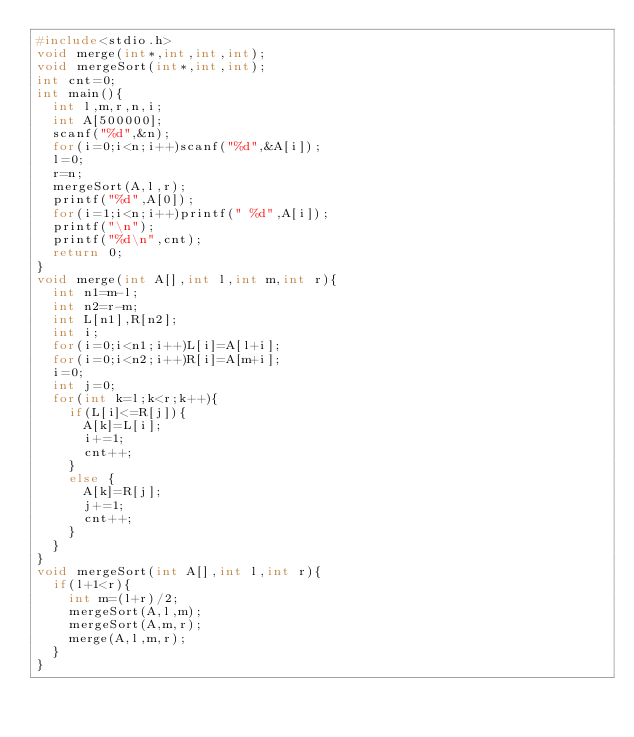Convert code to text. <code><loc_0><loc_0><loc_500><loc_500><_C_>#include<stdio.h>
void merge(int*,int,int,int);
void mergeSort(int*,int,int);
int cnt=0;
int main(){
  int l,m,r,n,i;
  int A[500000];
  scanf("%d",&n);
  for(i=0;i<n;i++)scanf("%d",&A[i]);
  l=0;
  r=n;
  mergeSort(A,l,r);
  printf("%d",A[0]);
  for(i=1;i<n;i++)printf(" %d",A[i]);
  printf("\n");
  printf("%d\n",cnt);
  return 0;
}
void merge(int A[],int l,int m,int r){
  int n1=m-l;
  int n2=r-m;
  int L[n1],R[n2];
  int i;
  for(i=0;i<n1;i++)L[i]=A[l+i];
  for(i=0;i<n2;i++)R[i]=A[m+i];
  i=0;
  int j=0;
  for(int k=l;k<r;k++){
    if(L[i]<=R[j]){
      A[k]=L[i];
      i+=1;
      cnt++;
    }
    else {
      A[k]=R[j];
      j+=1;
      cnt++;
    }
  }
}
void mergeSort(int A[],int l,int r){
  if(l+1<r){
    int m=(l+r)/2;
    mergeSort(A,l,m);
    mergeSort(A,m,r);
    merge(A,l,m,r);
  }
}

</code> 